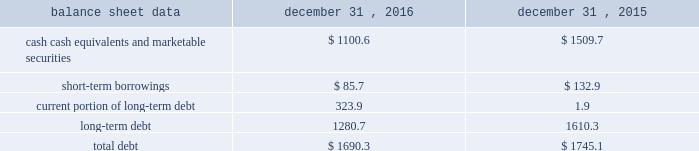Management 2019s discussion and analysis of financial condition and results of operations 2013 ( continued ) ( amounts in millions , except per share amounts ) the effect of foreign exchange rate changes on cash and cash equivalents included in the consolidated statements of cash flows resulted in a decrease of $ 156.1 in 2015 .
The decrease was primarily a result of the u.s .
Dollar being stronger than several foreign currencies , including the australian dollar , brazilian real , canadian dollar , euro and south african rand as of december 31 , 2015 compared to december 31 , 2014. .
Liquidity outlook we expect our cash flow from operations , cash and cash equivalents to be sufficient to meet our anticipated operating requirements at a minimum for the next twelve months .
We also have a committed corporate credit facility as well as uncommitted facilities available to support our operating needs .
We continue to maintain a disciplined approach to managing liquidity , with flexibility over significant uses of cash , including our capital expenditures , cash used for new acquisitions , our common stock repurchase program and our common stock dividends .
From time to time , we evaluate market conditions and financing alternatives for opportunities to raise additional funds or otherwise improve our liquidity profile , enhance our financial flexibility and manage market risk .
Our ability to access the capital markets depends on a number of factors , which include those specific to us , such as our credit rating , and those related to the financial markets , such as the amount or terms of available credit .
There can be no guarantee that we would be able to access new sources of liquidity on commercially reasonable terms , or at all .
Funding requirements our most significant funding requirements include our operations , non-cancelable operating lease obligations , capital expenditures , acquisitions , common stock dividends , taxes and debt service .
Additionally , we may be required to make payments to minority shareholders in certain subsidiaries if they exercise their options to sell us their equity interests .
Notable funding requirements include : 2022 debt service 2013 our 2.25% ( 2.25 % ) senior notes in aggregate principal amount of $ 300.0 mature on november 15 , 2017 , and a $ 22.6 note classified within our other notes payable is due on june 30 , 2017 .
We expect to use available cash to fund the retirement of the outstanding notes upon maturity .
The remainder of our debt is primarily long-term , with maturities scheduled through 2024 .
See the table below for the maturity schedule of our long-term debt .
2022 acquisitions 2013 we paid cash of $ 52.1 , net of cash acquired of $ 13.6 , for acquisitions completed in 2016 .
We also paid $ 0.5 in up-front payments and $ 59.3 in deferred payments for prior-year acquisitions as well as ownership increases in our consolidated subsidiaries .
In addition to potential cash expenditures for new acquisitions , we expect to pay approximately $ 77.0 in 2017 related to prior-year acquisitions .
We may also be required to pay approximately $ 31.0 in 2017 related to put options held by minority shareholders if exercised .
We will continue to evaluate strategic opportunities to grow and continue to strengthen our market position , particularly in our digital and marketing services offerings , and to expand our presence in high-growth and key strategic world markets .
2022 dividends 2013 during 2016 , we paid four quarterly cash dividends of $ 0.15 per share on our common stock , which corresponded to aggregate dividend payments of $ 238.4 .
On february 10 , 2017 , we announced that our board of directors ( the 201cboard 201d ) had declared a common stock cash dividend of $ 0.18 per share , payable on march 15 , 2017 to holders of record as of the close of business on march 1 , 2017 .
Assuming we pay a quarterly dividend of $ 0.18 per share and there is no significant change in the number of outstanding shares as of december 31 , 2016 , we would expect to pay approximately $ 280.0 over the next twelve months. .
What is the average quarterly dividend payment in 2016 , ( in millions ) ? 
Computations: (238.4 / 4)
Answer: 59.6. 